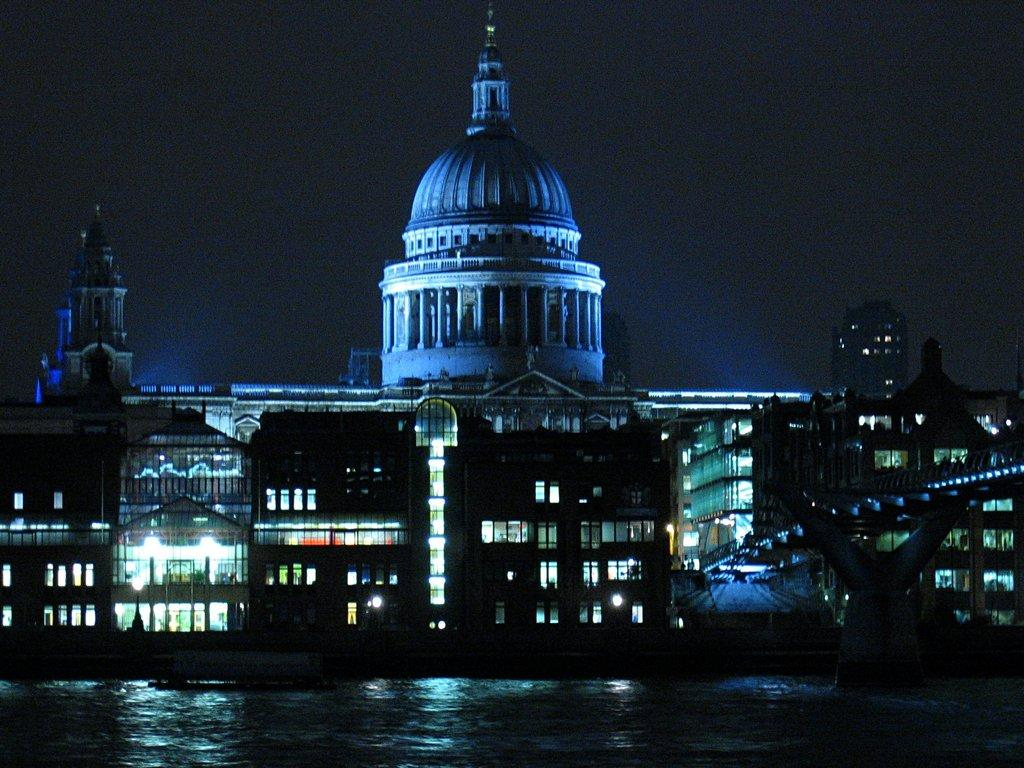What is the primary element present in the image? There is water in the image. What type of artwork can be seen in the image? There is a sculpture in the image. What can be seen in the distance in the image? There are buildings in the background of the image. What is visible above the buildings in the image? The sky is visible in the background of the image. What type of cracker is being used to feed the goat in the image? There is no goat or cracker present in the image. 